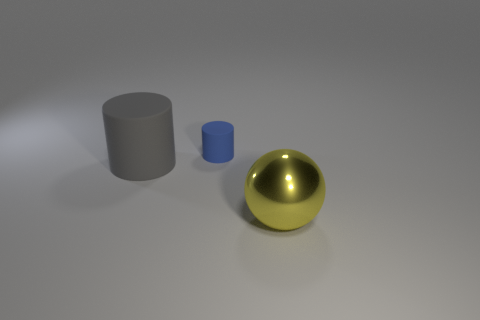Add 1 small red shiny blocks. How many objects exist? 4 Subtract all balls. How many objects are left? 2 Subtract 1 blue cylinders. How many objects are left? 2 Subtract all big gray rubber objects. Subtract all big gray cylinders. How many objects are left? 1 Add 2 blue cylinders. How many blue cylinders are left? 3 Add 1 yellow shiny objects. How many yellow shiny objects exist? 2 